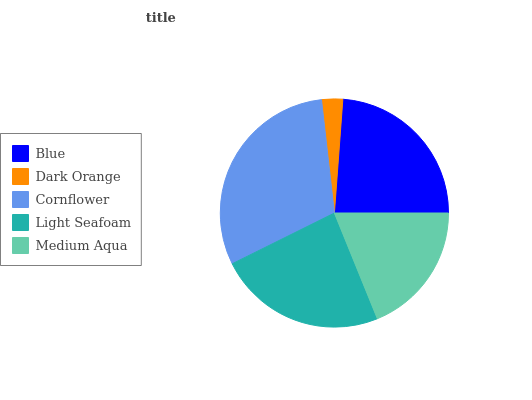Is Dark Orange the minimum?
Answer yes or no. Yes. Is Cornflower the maximum?
Answer yes or no. Yes. Is Cornflower the minimum?
Answer yes or no. No. Is Dark Orange the maximum?
Answer yes or no. No. Is Cornflower greater than Dark Orange?
Answer yes or no. Yes. Is Dark Orange less than Cornflower?
Answer yes or no. Yes. Is Dark Orange greater than Cornflower?
Answer yes or no. No. Is Cornflower less than Dark Orange?
Answer yes or no. No. Is Light Seafoam the high median?
Answer yes or no. Yes. Is Light Seafoam the low median?
Answer yes or no. Yes. Is Medium Aqua the high median?
Answer yes or no. No. Is Blue the low median?
Answer yes or no. No. 